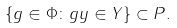Convert formula to latex. <formula><loc_0><loc_0><loc_500><loc_500>\{ g \in \Phi \colon g y \in Y \} \subset P .</formula> 